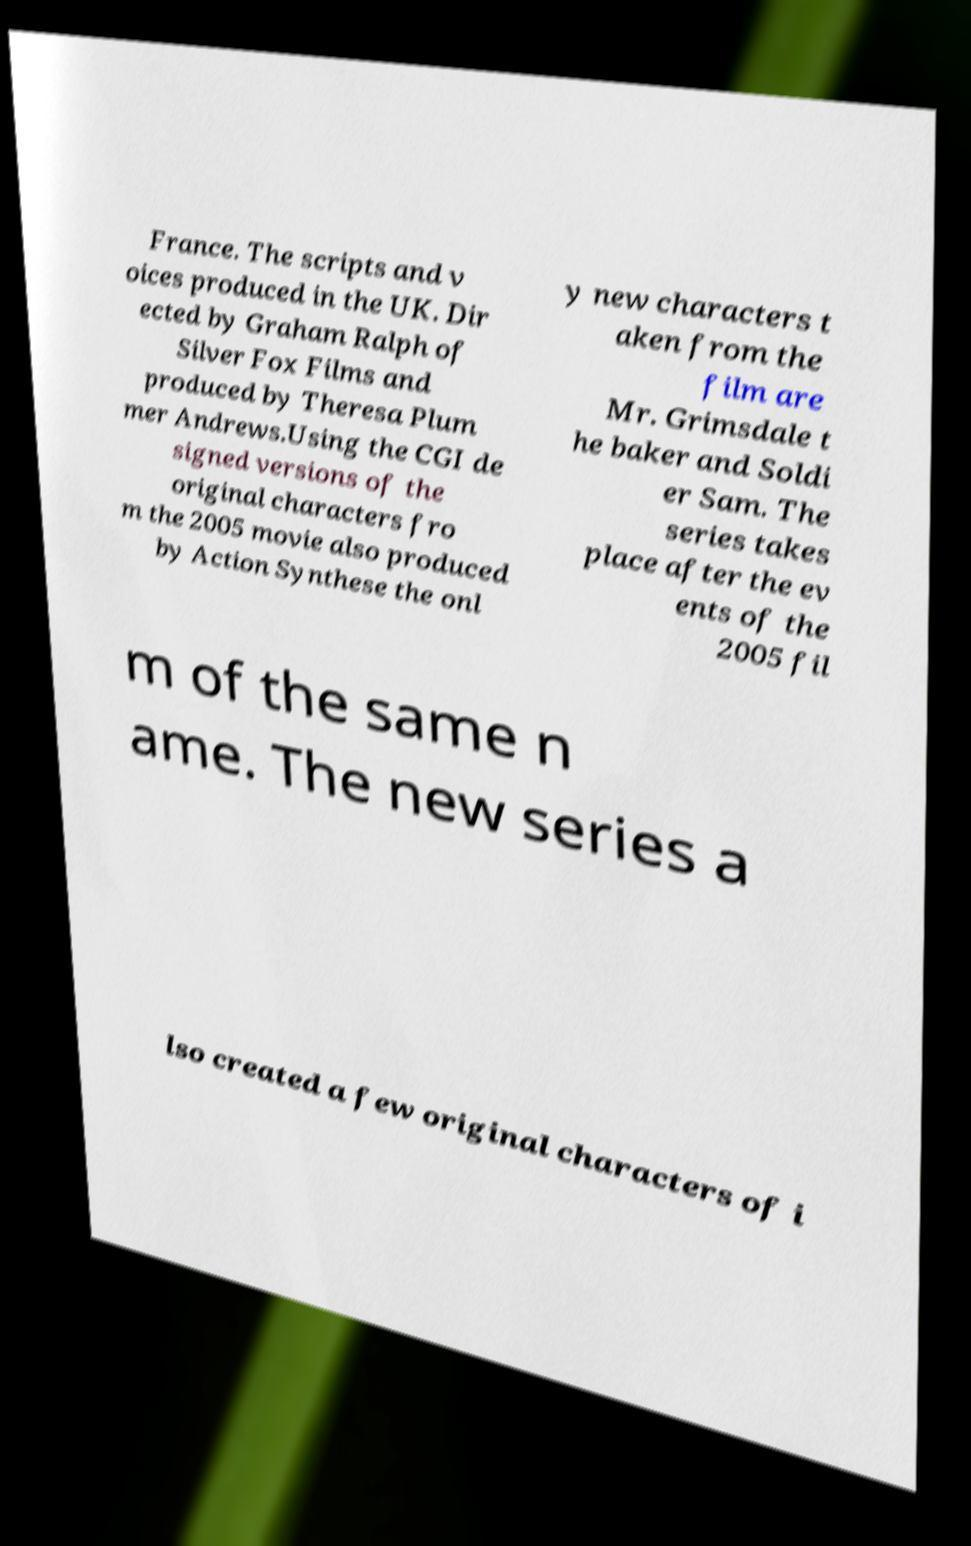Can you accurately transcribe the text from the provided image for me? France. The scripts and v oices produced in the UK. Dir ected by Graham Ralph of Silver Fox Films and produced by Theresa Plum mer Andrews.Using the CGI de signed versions of the original characters fro m the 2005 movie also produced by Action Synthese the onl y new characters t aken from the film are Mr. Grimsdale t he baker and Soldi er Sam. The series takes place after the ev ents of the 2005 fil m of the same n ame. The new series a lso created a few original characters of i 